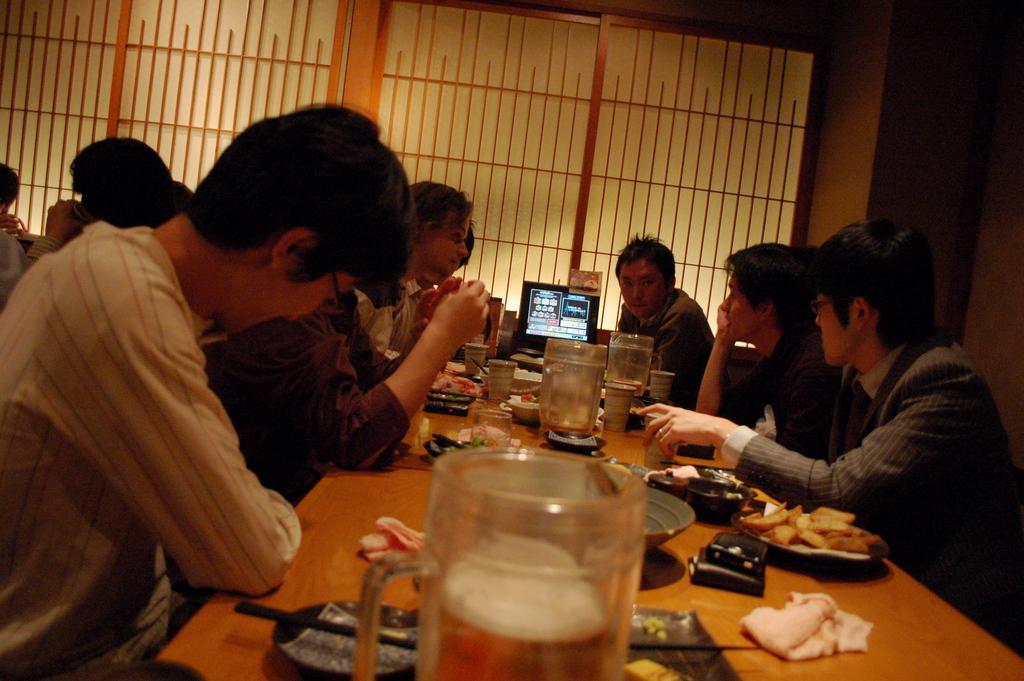Describe this image in one or two sentences. In this image we can see people sitting and there is a table. We can see jars, plates, napkin, glasses and some food placed on the table. In the background there is a screen, wall and windows. 